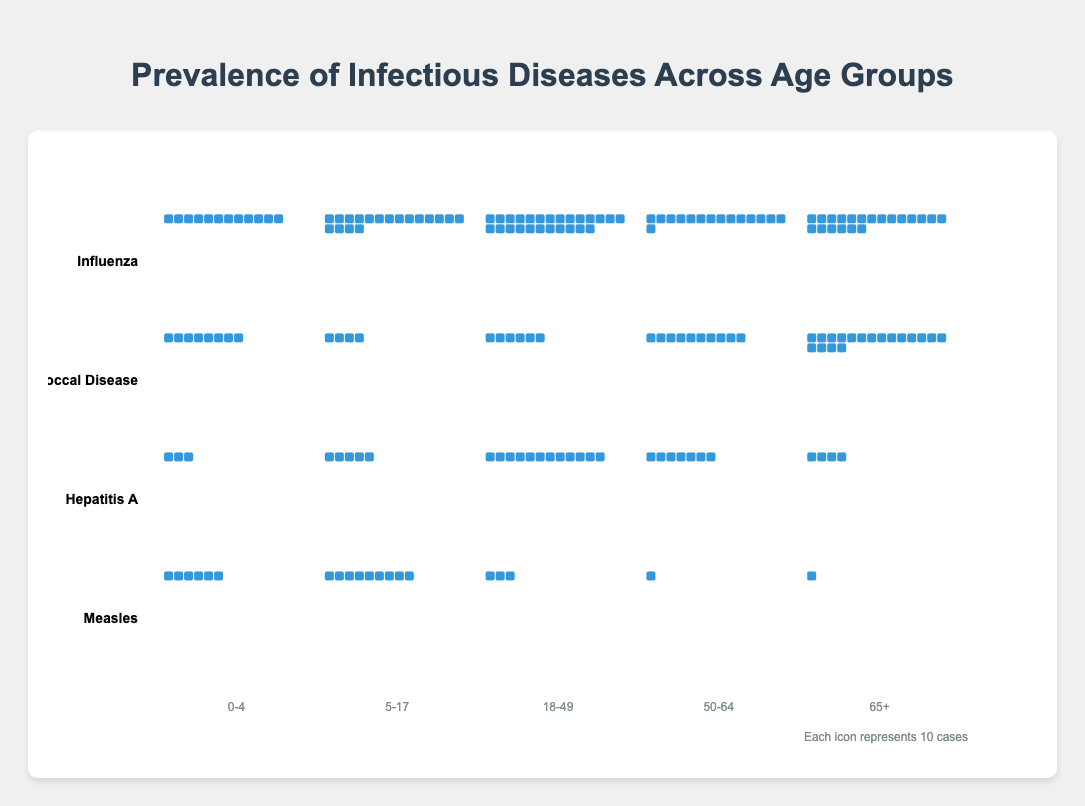What's the title of the figure? The title of the figure is positioned at the top, centered in the plot area and features a large, distinct font. It aims to give a quick indication of what the plot represents.
Answer: Prevalence of Infectious Diseases Across Age Groups Which age group has the highest number of Influenza cases? By observing the icons representing cases for each age group under the Influenza category, the group with the fullest row of icons indicates the highest cases. The 18-49 group is the most extensive.
Answer: 18-49 Which disease has the fewest cases in the 0-4 age group? Look for the age group labeled 0-4 for each disease and count the icons representing cases. Hepatitis A has the smallest number of icons.
Answer: Hepatitis A Compare the number of cases of Pneumococcal Disease for the age groups 5-17 and 50-64. Which group is larger? Check the number of icons under the labels 5-17 and 50-64 for Pneumococcal Disease, and compare. The 50-64 age group has more icons.
Answer: 50-64 What is the total number of Measles cases across all age groups? Sum the number of icons representing Measles cases in each age group: 60 (0-4) + 90 (5-17) + 30 (18-49) + 10 (50-64) + 5 (65+).
Answer: 195 Which age group shows the lowest prevalence of Pneumococcal Disease and Measles combined? For Pneumococcal Disease and Measles, find each age group's combined total by summing the corresponding icons and identify the minimum. The 65+ group is the smallest.
Answer: 65+ How does the prevalence of Hepatitis A in the 18-49 age group compare to that in the 5-17 age group? Count the number of icons for Hepatitis A in both 18-49 and 5-17 age groups. Next, compare the numbers; 18-49 has more icons than 5-17.
Answer: 18-49 is more prevalent Which disease has a higher peak prevalence in one specific age group? Identify the age group with the maximum icons for each disease, then compare these peaks. Influenza in the 18-49 group has the highest single peak.
Answer: Influenza Which disease shows a steady increase in prevalence across the age groups? By examining each disease and observing the trend of icons rising incrementally with age group labels, Pneumococcal Disease steadily increases.
Answer: Pneumococcal Disease 